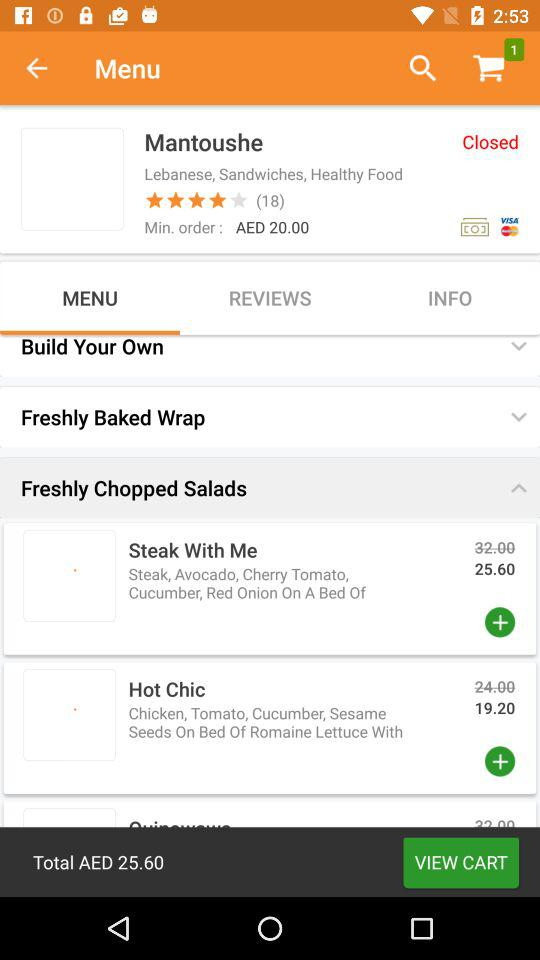What is the rating? The rating is 4 stars. 